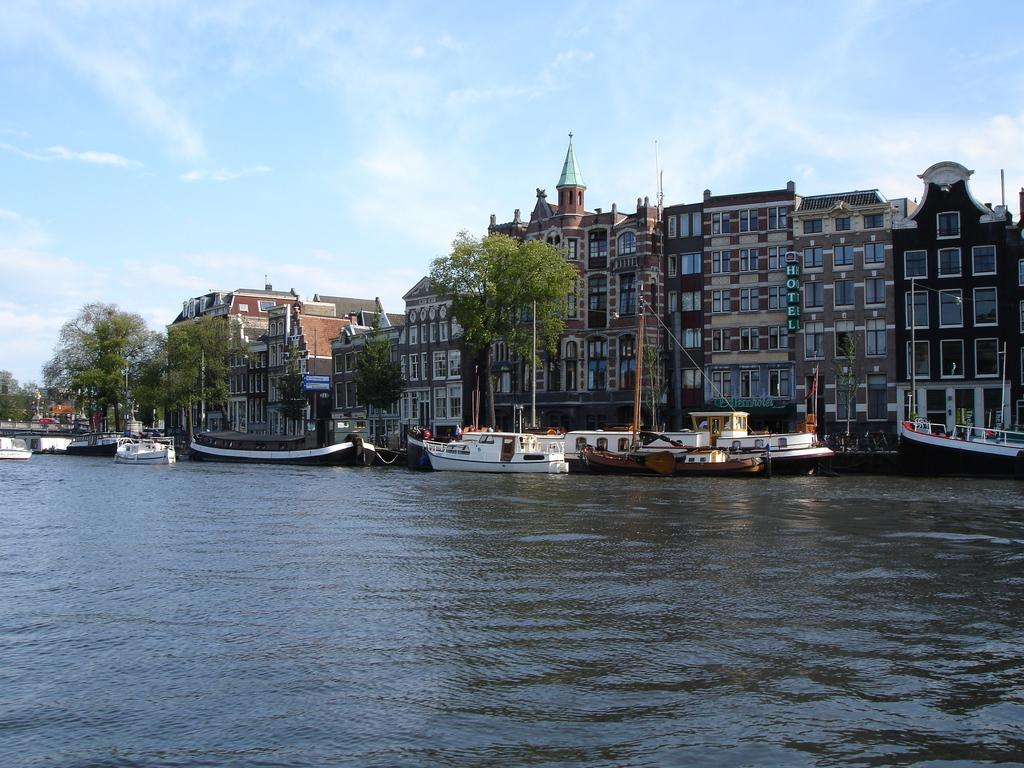What is the main subject of the image? The main subject of the image is boats. Where are the boats located? The boats are on a river. What can be seen in the background of the image? There are trees, buildings, and the sky visible in the background of the image. What type of beam is holding up the sweater in the image? There is no beam or sweater present in the image; it features boats on a river with trees, buildings, and the sky in the background. 